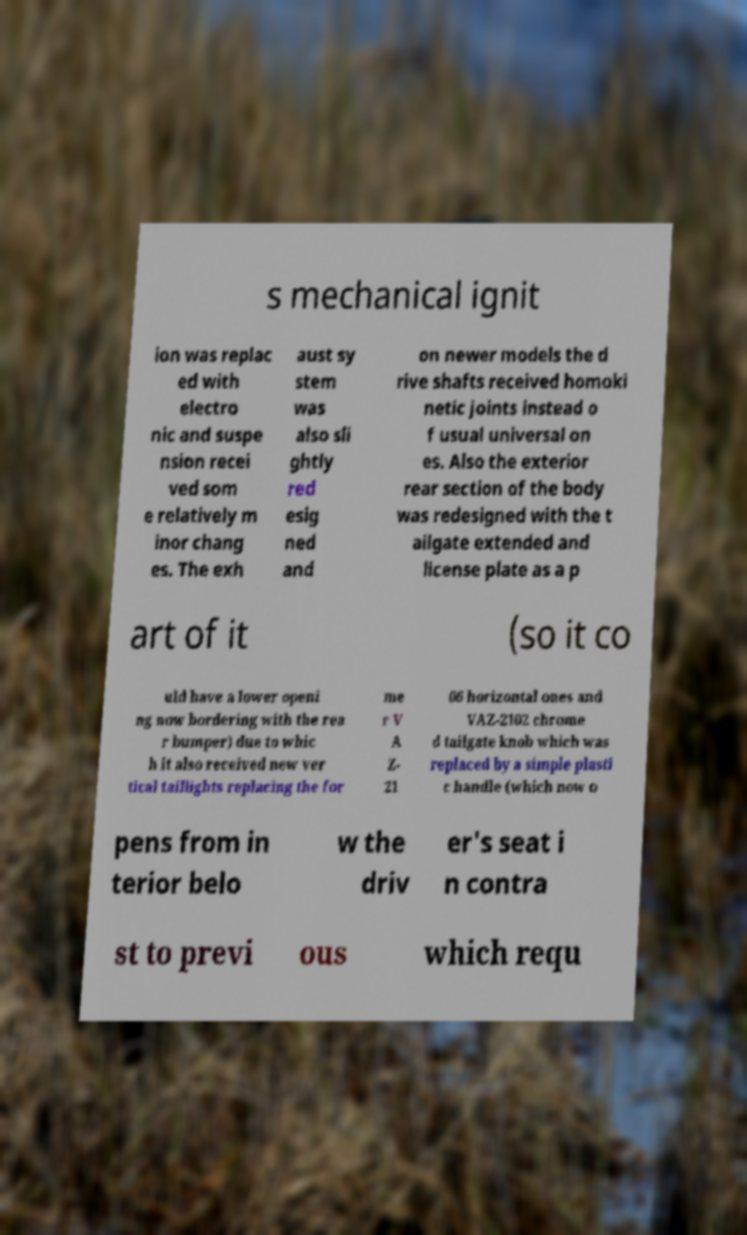Could you assist in decoding the text presented in this image and type it out clearly? s mechanical ignit ion was replac ed with electro nic and suspe nsion recei ved som e relatively m inor chang es. The exh aust sy stem was also sli ghtly red esig ned and on newer models the d rive shafts received homoki netic joints instead o f usual universal on es. Also the exterior rear section of the body was redesigned with the t ailgate extended and license plate as a p art of it (so it co uld have a lower openi ng now bordering with the rea r bumper) due to whic h it also received new ver tical taillights replacing the for me r V A Z- 21 06 horizontal ones and VAZ-2102 chrome d tailgate knob which was replaced by a simple plasti c handle (which now o pens from in terior belo w the driv er's seat i n contra st to previ ous which requ 